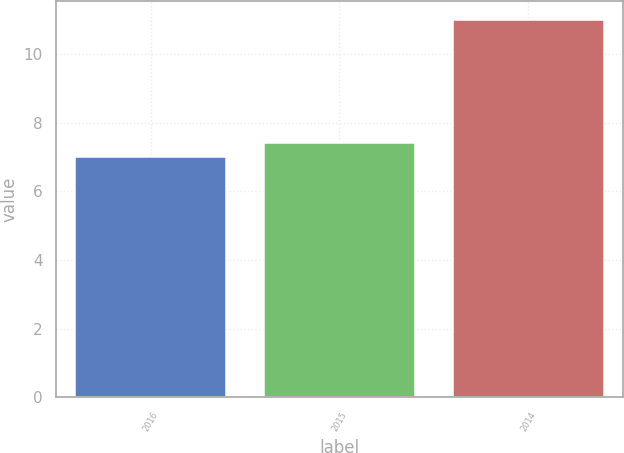<chart> <loc_0><loc_0><loc_500><loc_500><bar_chart><fcel>2016<fcel>2015<fcel>2014<nl><fcel>7<fcel>7.4<fcel>11<nl></chart> 